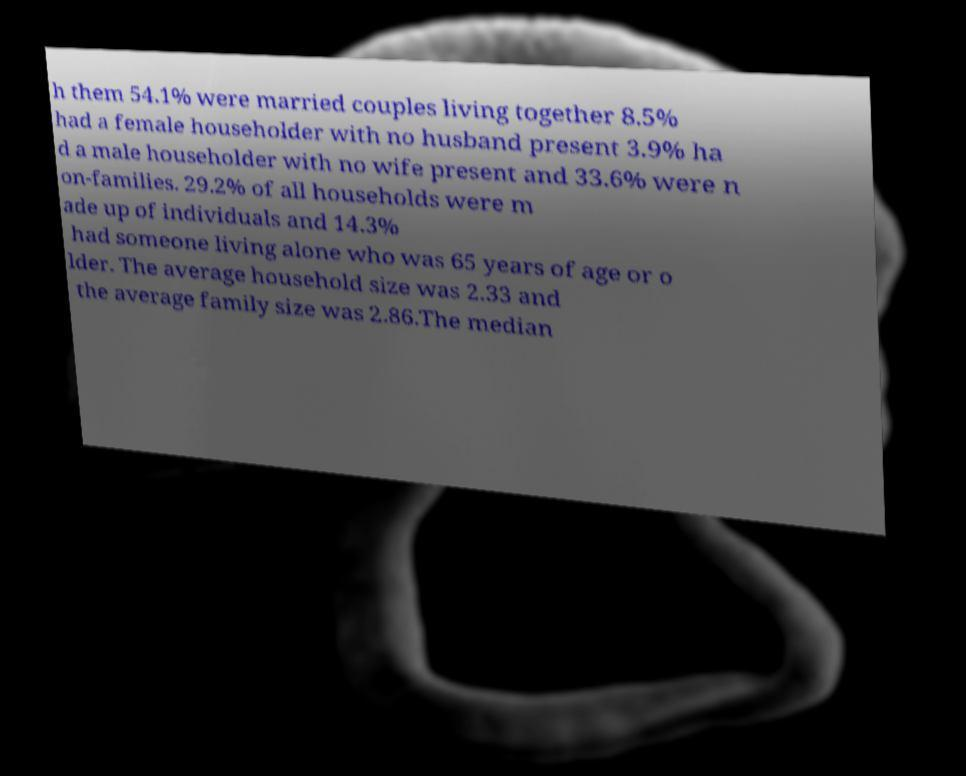Please identify and transcribe the text found in this image. h them 54.1% were married couples living together 8.5% had a female householder with no husband present 3.9% ha d a male householder with no wife present and 33.6% were n on-families. 29.2% of all households were m ade up of individuals and 14.3% had someone living alone who was 65 years of age or o lder. The average household size was 2.33 and the average family size was 2.86.The median 